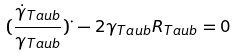Convert formula to latex. <formula><loc_0><loc_0><loc_500><loc_500>( \frac { \dot { \gamma } _ { T a u b } } { \gamma _ { T a u b } } ) ^ { \cdot } - 2 \gamma _ { T a u b } R _ { T a u b } = 0</formula> 